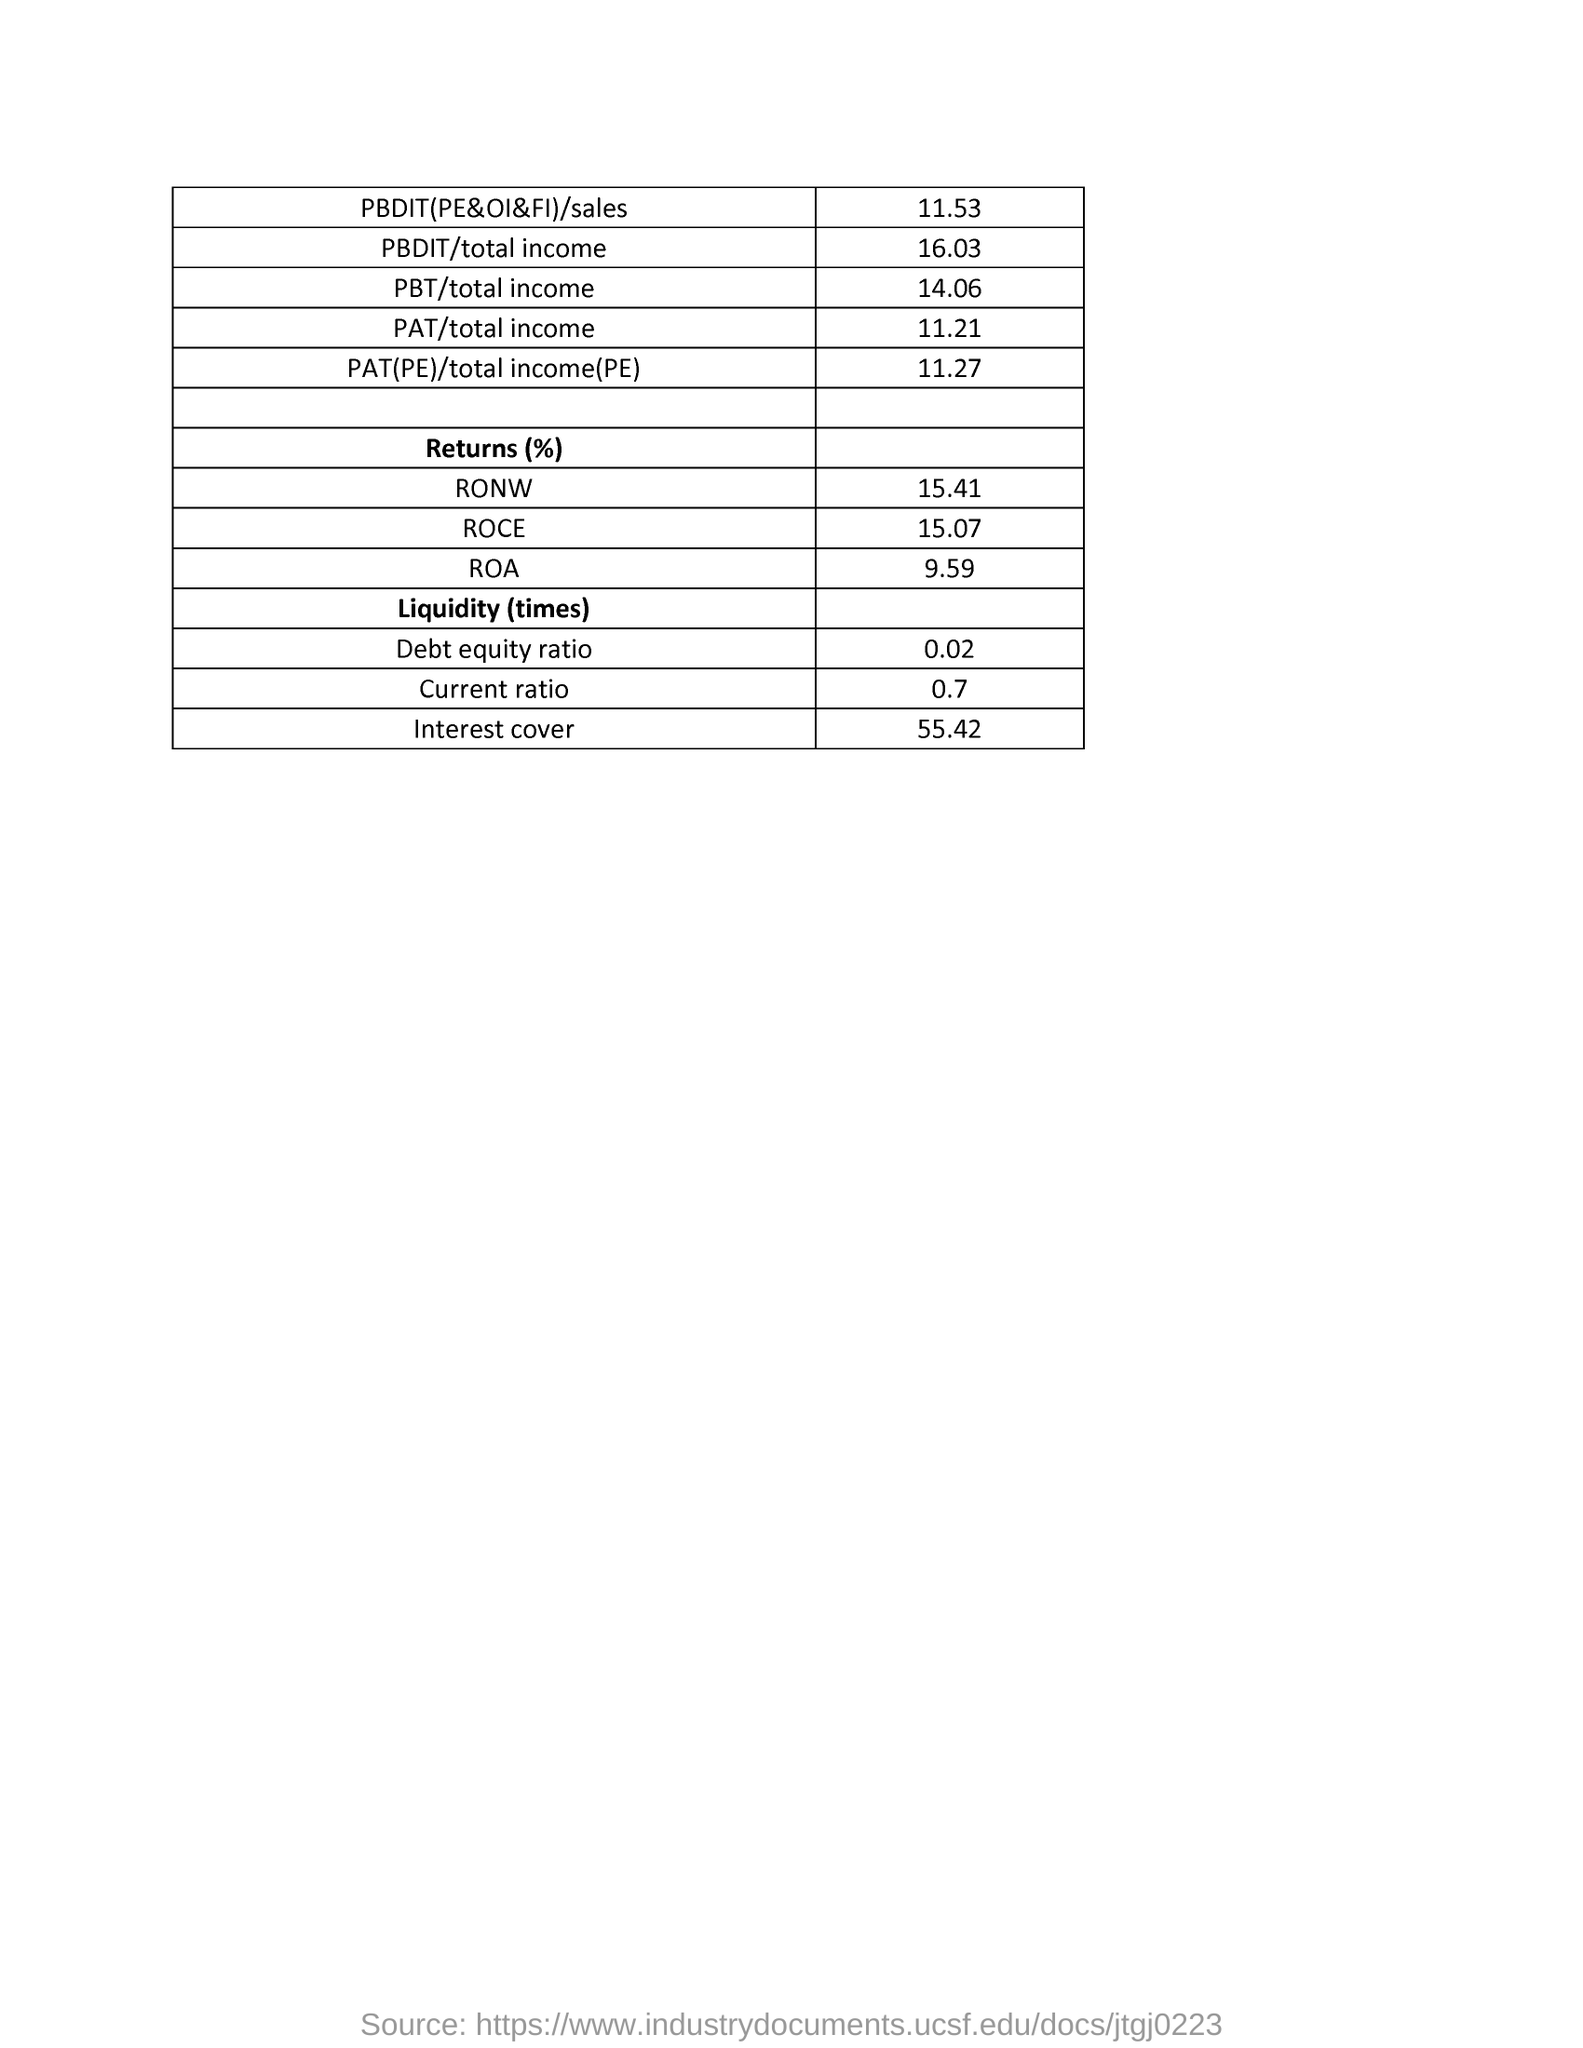Outline some significant characteristics in this image. The return rate of RONW is 15.41%. The debt-to-equity ratio is 0.02. The total income for PAT(PE) is 11.27. The PBDIT sales for the current period is 11.53. The interest cover is 55.42. 